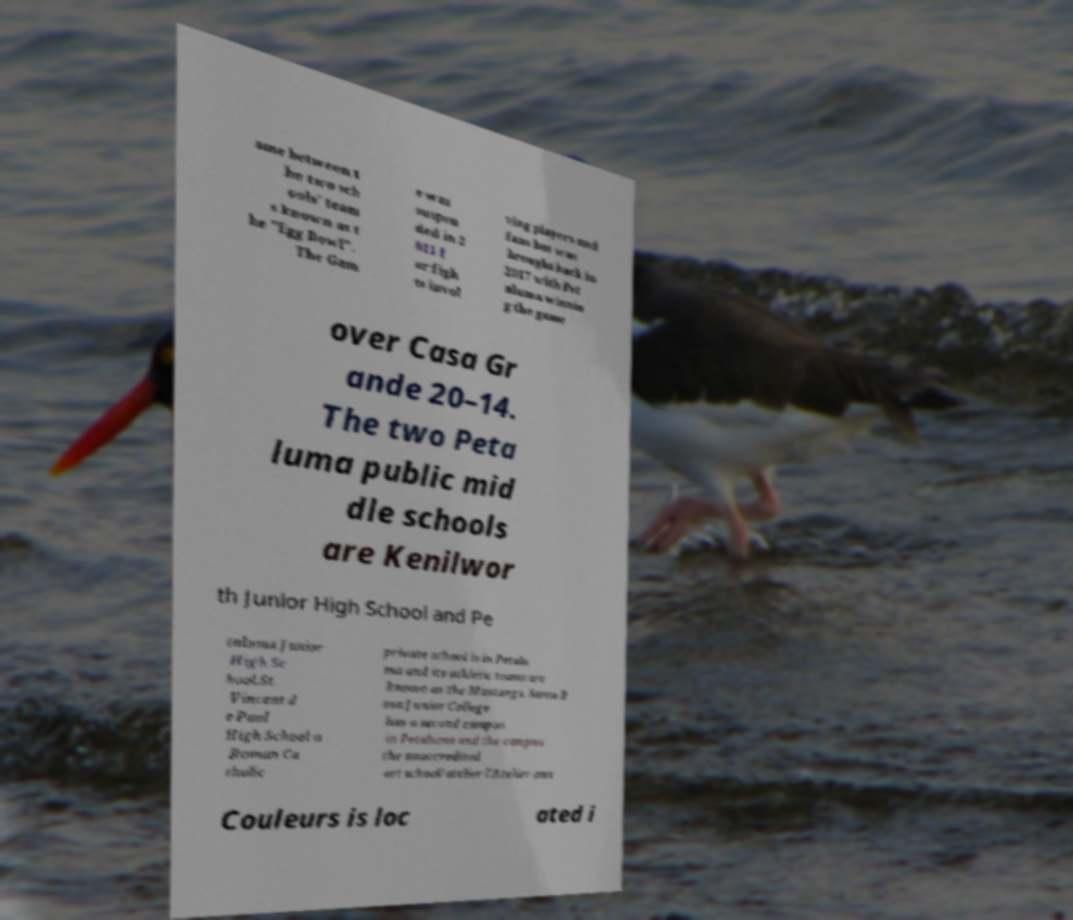For documentation purposes, I need the text within this image transcribed. Could you provide that? ame between t he two sch ools' team s known as t he "Egg Bowl". The Gam e was suspen ded in 2 011 f or figh ts invol ving players and fans but was brought back in 2017 with Pet aluma winnin g the game over Casa Gr ande 20–14. The two Peta luma public mid dle schools are Kenilwor th Junior High School and Pe taluma Junior High Sc hool.St. Vincent d e Paul High School a Roman Ca tholic private school is in Petalu ma and its athletic teams are known as the Mustangs. Santa R osa Junior College has a second campus in Petaluma and the campus the unaccredited art school/atelier l'Atelier aux Couleurs is loc ated i 